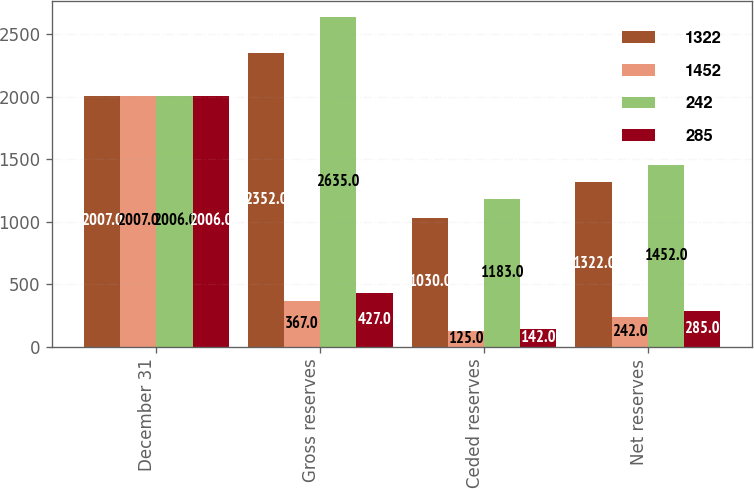Convert chart to OTSL. <chart><loc_0><loc_0><loc_500><loc_500><stacked_bar_chart><ecel><fcel>December 31<fcel>Gross reserves<fcel>Ceded reserves<fcel>Net reserves<nl><fcel>1322<fcel>2007<fcel>2352<fcel>1030<fcel>1322<nl><fcel>1452<fcel>2007<fcel>367<fcel>125<fcel>242<nl><fcel>242<fcel>2006<fcel>2635<fcel>1183<fcel>1452<nl><fcel>285<fcel>2006<fcel>427<fcel>142<fcel>285<nl></chart> 